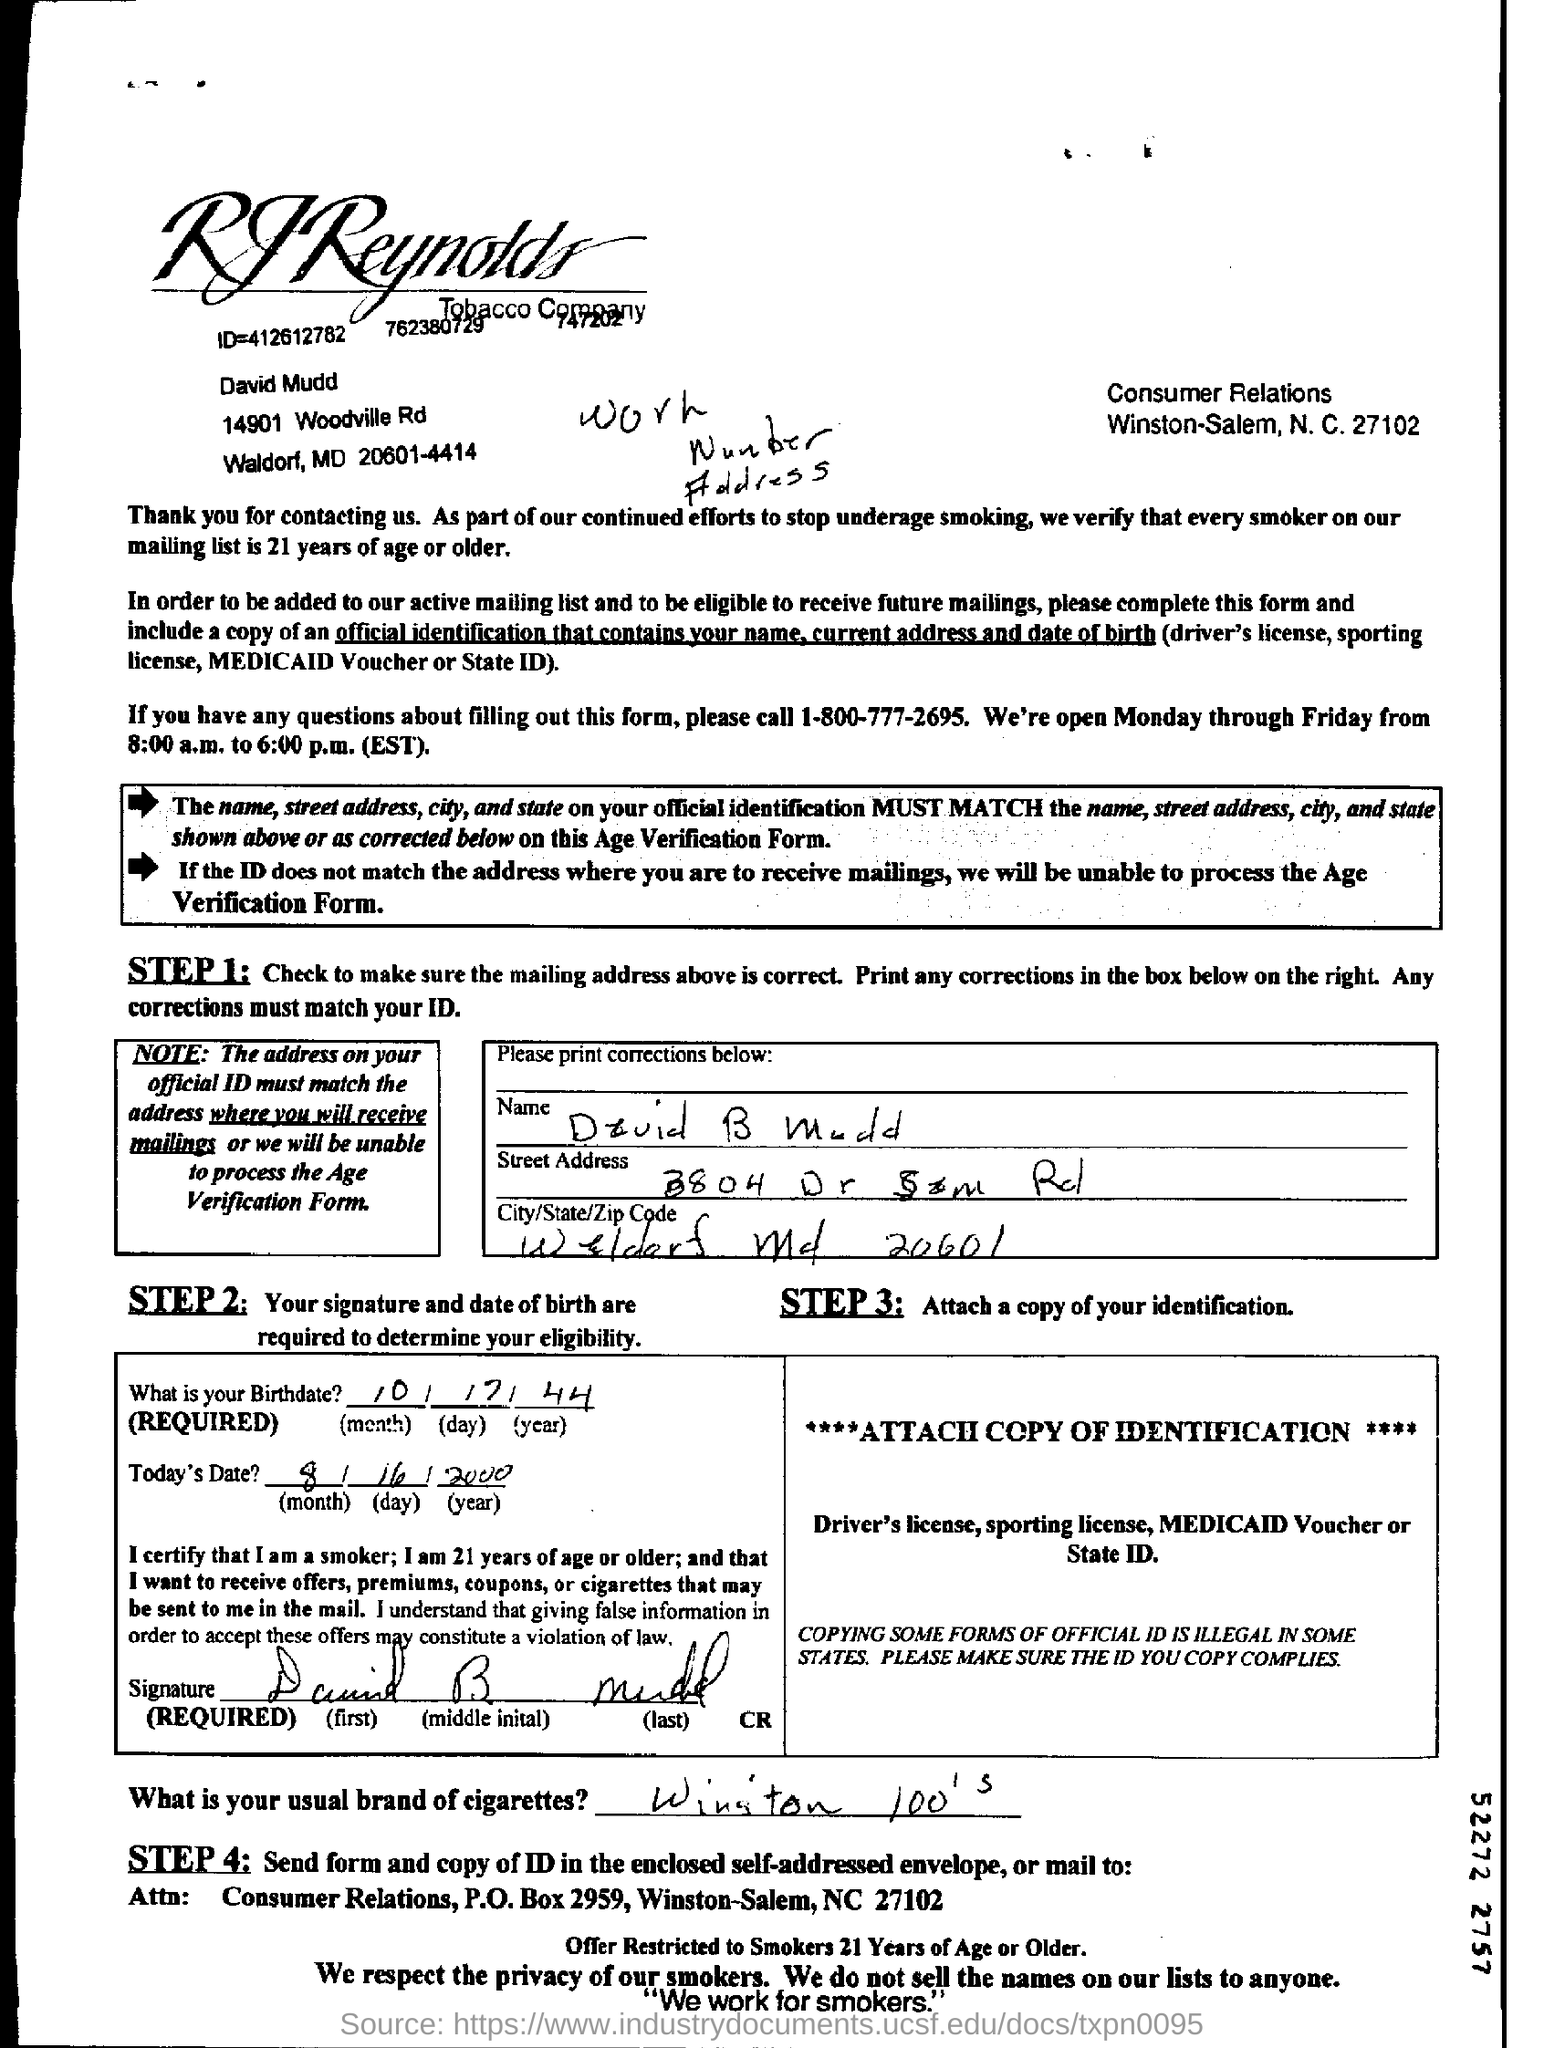Highlight a few significant elements in this photo. The birthdate is October 17, 1944. The name of the tobacco company is RJReynolds Tobacco Company. The NC number is 27102. Today's date is August 16, 2000. 1-800-777-2695 is the telephone number that should be dialed for any inquiries. 